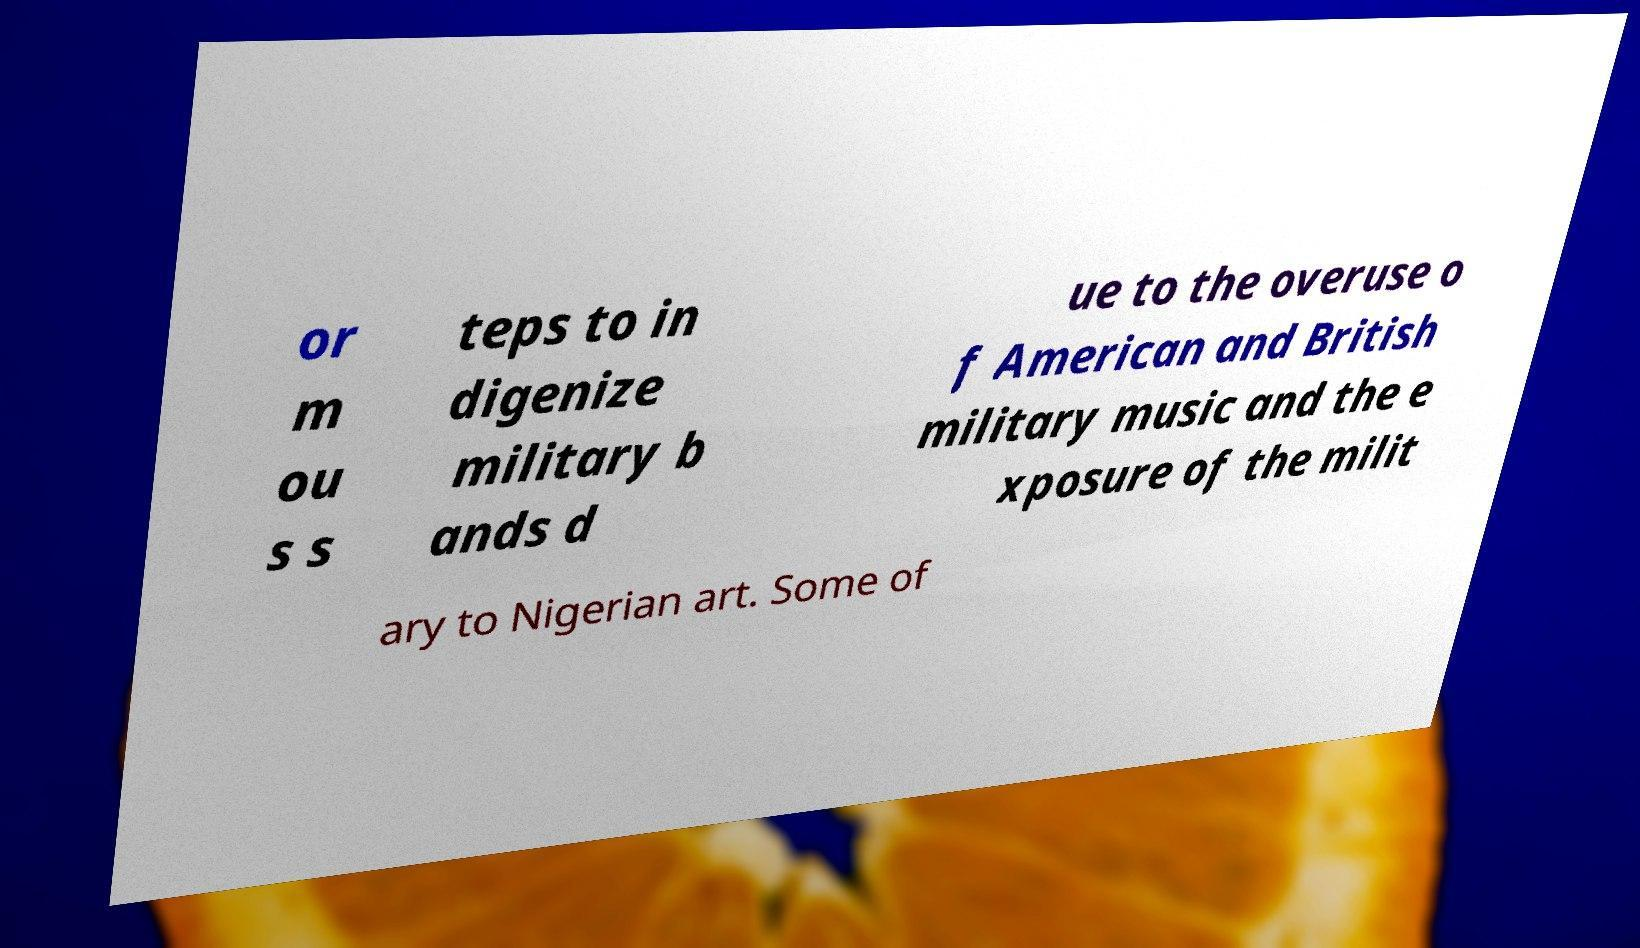Can you read and provide the text displayed in the image?This photo seems to have some interesting text. Can you extract and type it out for me? or m ou s s teps to in digenize military b ands d ue to the overuse o f American and British military music and the e xposure of the milit ary to Nigerian art. Some of 